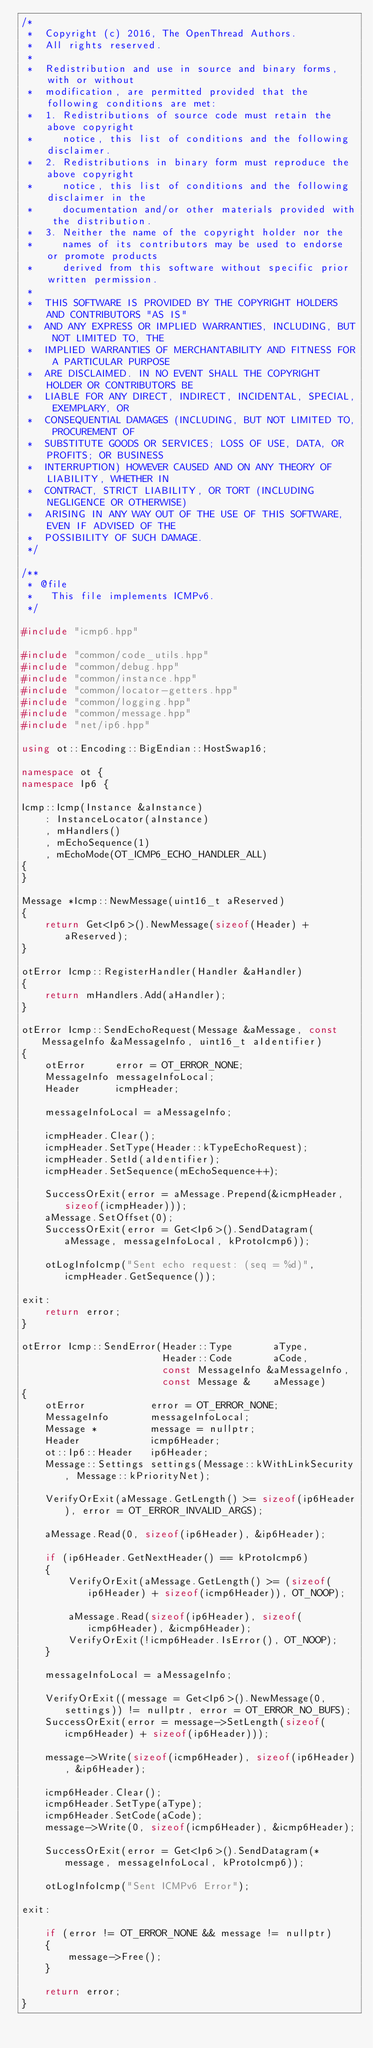<code> <loc_0><loc_0><loc_500><loc_500><_C++_>/*
 *  Copyright (c) 2016, The OpenThread Authors.
 *  All rights reserved.
 *
 *  Redistribution and use in source and binary forms, with or without
 *  modification, are permitted provided that the following conditions are met:
 *  1. Redistributions of source code must retain the above copyright
 *     notice, this list of conditions and the following disclaimer.
 *  2. Redistributions in binary form must reproduce the above copyright
 *     notice, this list of conditions and the following disclaimer in the
 *     documentation and/or other materials provided with the distribution.
 *  3. Neither the name of the copyright holder nor the
 *     names of its contributors may be used to endorse or promote products
 *     derived from this software without specific prior written permission.
 *
 *  THIS SOFTWARE IS PROVIDED BY THE COPYRIGHT HOLDERS AND CONTRIBUTORS "AS IS"
 *  AND ANY EXPRESS OR IMPLIED WARRANTIES, INCLUDING, BUT NOT LIMITED TO, THE
 *  IMPLIED WARRANTIES OF MERCHANTABILITY AND FITNESS FOR A PARTICULAR PURPOSE
 *  ARE DISCLAIMED. IN NO EVENT SHALL THE COPYRIGHT HOLDER OR CONTRIBUTORS BE
 *  LIABLE FOR ANY DIRECT, INDIRECT, INCIDENTAL, SPECIAL, EXEMPLARY, OR
 *  CONSEQUENTIAL DAMAGES (INCLUDING, BUT NOT LIMITED TO, PROCUREMENT OF
 *  SUBSTITUTE GOODS OR SERVICES; LOSS OF USE, DATA, OR PROFITS; OR BUSINESS
 *  INTERRUPTION) HOWEVER CAUSED AND ON ANY THEORY OF LIABILITY, WHETHER IN
 *  CONTRACT, STRICT LIABILITY, OR TORT (INCLUDING NEGLIGENCE OR OTHERWISE)
 *  ARISING IN ANY WAY OUT OF THE USE OF THIS SOFTWARE, EVEN IF ADVISED OF THE
 *  POSSIBILITY OF SUCH DAMAGE.
 */

/**
 * @file
 *   This file implements ICMPv6.
 */

#include "icmp6.hpp"

#include "common/code_utils.hpp"
#include "common/debug.hpp"
#include "common/instance.hpp"
#include "common/locator-getters.hpp"
#include "common/logging.hpp"
#include "common/message.hpp"
#include "net/ip6.hpp"

using ot::Encoding::BigEndian::HostSwap16;

namespace ot {
namespace Ip6 {

Icmp::Icmp(Instance &aInstance)
    : InstanceLocator(aInstance)
    , mHandlers()
    , mEchoSequence(1)
    , mEchoMode(OT_ICMP6_ECHO_HANDLER_ALL)
{
}

Message *Icmp::NewMessage(uint16_t aReserved)
{
    return Get<Ip6>().NewMessage(sizeof(Header) + aReserved);
}

otError Icmp::RegisterHandler(Handler &aHandler)
{
    return mHandlers.Add(aHandler);
}

otError Icmp::SendEchoRequest(Message &aMessage, const MessageInfo &aMessageInfo, uint16_t aIdentifier)
{
    otError     error = OT_ERROR_NONE;
    MessageInfo messageInfoLocal;
    Header      icmpHeader;

    messageInfoLocal = aMessageInfo;

    icmpHeader.Clear();
    icmpHeader.SetType(Header::kTypeEchoRequest);
    icmpHeader.SetId(aIdentifier);
    icmpHeader.SetSequence(mEchoSequence++);

    SuccessOrExit(error = aMessage.Prepend(&icmpHeader, sizeof(icmpHeader)));
    aMessage.SetOffset(0);
    SuccessOrExit(error = Get<Ip6>().SendDatagram(aMessage, messageInfoLocal, kProtoIcmp6));

    otLogInfoIcmp("Sent echo request: (seq = %d)", icmpHeader.GetSequence());

exit:
    return error;
}

otError Icmp::SendError(Header::Type       aType,
                        Header::Code       aCode,
                        const MessageInfo &aMessageInfo,
                        const Message &    aMessage)
{
    otError           error = OT_ERROR_NONE;
    MessageInfo       messageInfoLocal;
    Message *         message = nullptr;
    Header            icmp6Header;
    ot::Ip6::Header   ip6Header;
    Message::Settings settings(Message::kWithLinkSecurity, Message::kPriorityNet);

    VerifyOrExit(aMessage.GetLength() >= sizeof(ip6Header), error = OT_ERROR_INVALID_ARGS);

    aMessage.Read(0, sizeof(ip6Header), &ip6Header);

    if (ip6Header.GetNextHeader() == kProtoIcmp6)
    {
        VerifyOrExit(aMessage.GetLength() >= (sizeof(ip6Header) + sizeof(icmp6Header)), OT_NOOP);

        aMessage.Read(sizeof(ip6Header), sizeof(icmp6Header), &icmp6Header);
        VerifyOrExit(!icmp6Header.IsError(), OT_NOOP);
    }

    messageInfoLocal = aMessageInfo;

    VerifyOrExit((message = Get<Ip6>().NewMessage(0, settings)) != nullptr, error = OT_ERROR_NO_BUFS);
    SuccessOrExit(error = message->SetLength(sizeof(icmp6Header) + sizeof(ip6Header)));

    message->Write(sizeof(icmp6Header), sizeof(ip6Header), &ip6Header);

    icmp6Header.Clear();
    icmp6Header.SetType(aType);
    icmp6Header.SetCode(aCode);
    message->Write(0, sizeof(icmp6Header), &icmp6Header);

    SuccessOrExit(error = Get<Ip6>().SendDatagram(*message, messageInfoLocal, kProtoIcmp6));

    otLogInfoIcmp("Sent ICMPv6 Error");

exit:

    if (error != OT_ERROR_NONE && message != nullptr)
    {
        message->Free();
    }

    return error;
}
</code> 